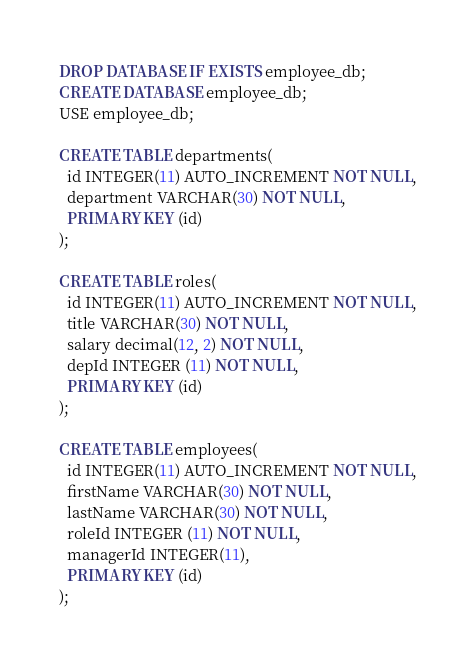Convert code to text. <code><loc_0><loc_0><loc_500><loc_500><_SQL_>DROP DATABASE IF EXISTS employee_db;
CREATE DATABASE employee_db;
USE employee_db;

CREATE TABLE departments(
  id INTEGER(11) AUTO_INCREMENT NOT NULL,
  department VARCHAR(30) NOT NULL,
  PRIMARY KEY (id)
);

CREATE TABLE roles(
  id INTEGER(11) AUTO_INCREMENT NOT NULL,
  title VARCHAR(30) NOT NULL,
  salary decimal(12, 2) NOT NULL,
  depId INTEGER (11) NOT NULL,
  PRIMARY KEY (id) 
);

CREATE TABLE employees(
  id INTEGER(11) AUTO_INCREMENT NOT NULL,
  firstName VARCHAR(30) NOT NULL,
  lastName VARCHAR(30) NOT NULL,
  roleId INTEGER (11) NOT NULL,
  managerId INTEGER(11),
  PRIMARY KEY (id)
); </code> 